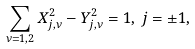Convert formula to latex. <formula><loc_0><loc_0><loc_500><loc_500>\sum _ { \nu = 1 , 2 } X _ { j , \nu } ^ { 2 } - Y _ { j , \nu } ^ { 2 } = 1 , \, j = \pm 1 ,</formula> 